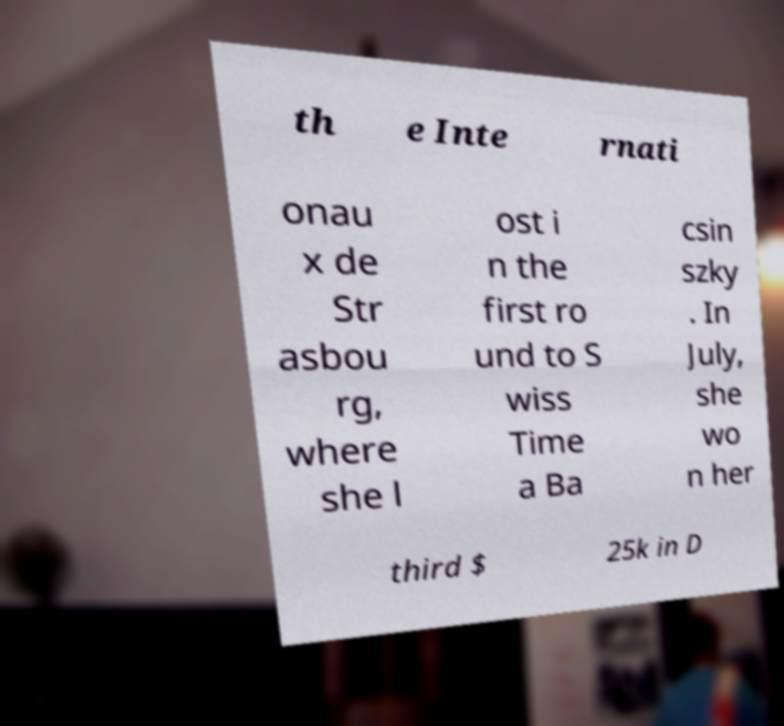There's text embedded in this image that I need extracted. Can you transcribe it verbatim? th e Inte rnati onau x de Str asbou rg, where she l ost i n the first ro und to S wiss Time a Ba csin szky . In July, she wo n her third $ 25k in D 